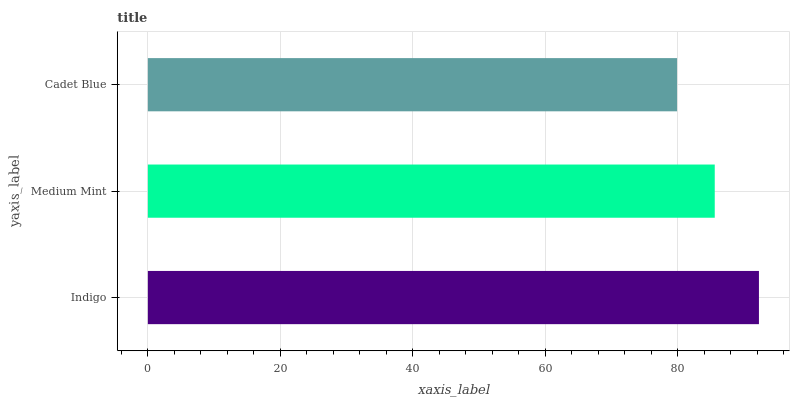Is Cadet Blue the minimum?
Answer yes or no. Yes. Is Indigo the maximum?
Answer yes or no. Yes. Is Medium Mint the minimum?
Answer yes or no. No. Is Medium Mint the maximum?
Answer yes or no. No. Is Indigo greater than Medium Mint?
Answer yes or no. Yes. Is Medium Mint less than Indigo?
Answer yes or no. Yes. Is Medium Mint greater than Indigo?
Answer yes or no. No. Is Indigo less than Medium Mint?
Answer yes or no. No. Is Medium Mint the high median?
Answer yes or no. Yes. Is Medium Mint the low median?
Answer yes or no. Yes. Is Cadet Blue the high median?
Answer yes or no. No. Is Indigo the low median?
Answer yes or no. No. 